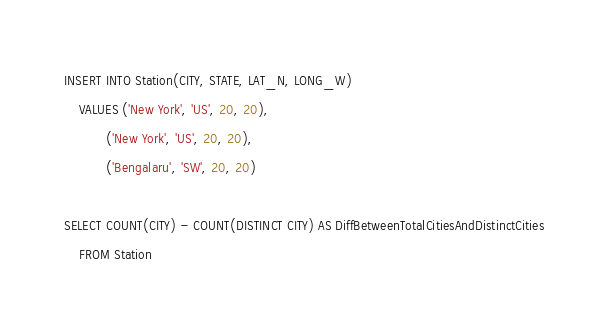Convert code to text. <code><loc_0><loc_0><loc_500><loc_500><_SQL_>INSERT INTO Station(CITY, STATE, LAT_N, LONG_W)
    VALUES ('New York', 'US', 20, 20),
           ('New York', 'US', 20, 20),
           ('Bengalaru', 'SW', 20, 20)

SELECT COUNT(CITY) - COUNT(DISTINCT CITY) AS DiffBetweenTotalCitiesAndDistinctCities
    FROM Station
</code> 